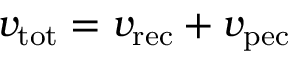Convert formula to latex. <formula><loc_0><loc_0><loc_500><loc_500>v _ { t o t } = v _ { r e c } + v _ { p e c }</formula> 